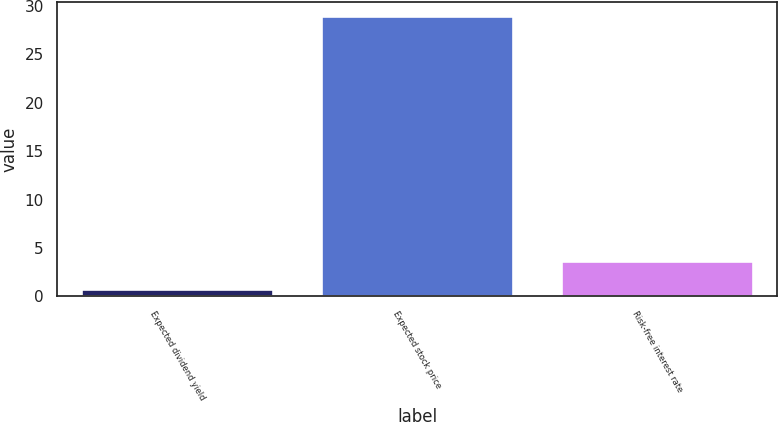<chart> <loc_0><loc_0><loc_500><loc_500><bar_chart><fcel>Expected dividend yield<fcel>Expected stock price<fcel>Risk-free interest rate<nl><fcel>0.79<fcel>28.99<fcel>3.61<nl></chart> 